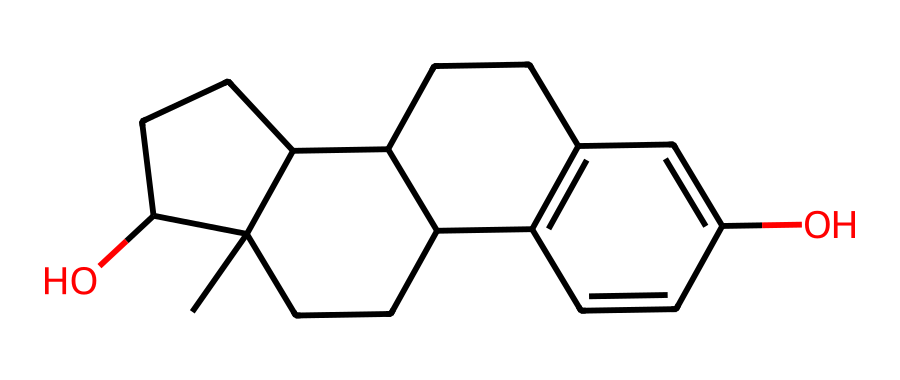What is the IUPAC name of this chemical? The structure represented by the SMILES corresponds to estradiol, which is a major estrogen hormone. The IUPAC name includes specific descriptors such as the number of carbon atoms and functional groups present.
Answer: estradiol How many carbon atoms are in the structure? By analyzing the SMILES notation and counting the 'C' symbols, we find there are 18 carbon atoms in total.
Answer: 18 What type of isomerism is demonstrated by this chemical? Geometric isomerism arises in this compound as it has different spatial arrangements due to the double bond, allowing for cis/trans configurations. This is specifically due to the presence of rings and double bonds in the structure.
Answer: geometric What functional groups are present in estradiol? The structure contains two hydroxyl (-OH) groups and is indicative of an alcohol function in estradiol, contributing to its chemical properties and behavior.
Answer: hydroxyl groups How many double bonds are in this molecule? Counting the connections represented by the double bonds in the structure, it shows two double bonds that indicate unsaturation within the carbon framework.
Answer: 2 What effect does geometric isomerism have on estradiol's function? Geometric isomerism can impact the biological activity of estradiol, influencing how it interacts with estrogen receptors and thereby affecting its effectiveness as a hormone replacement therapy.
Answer: biological activity 